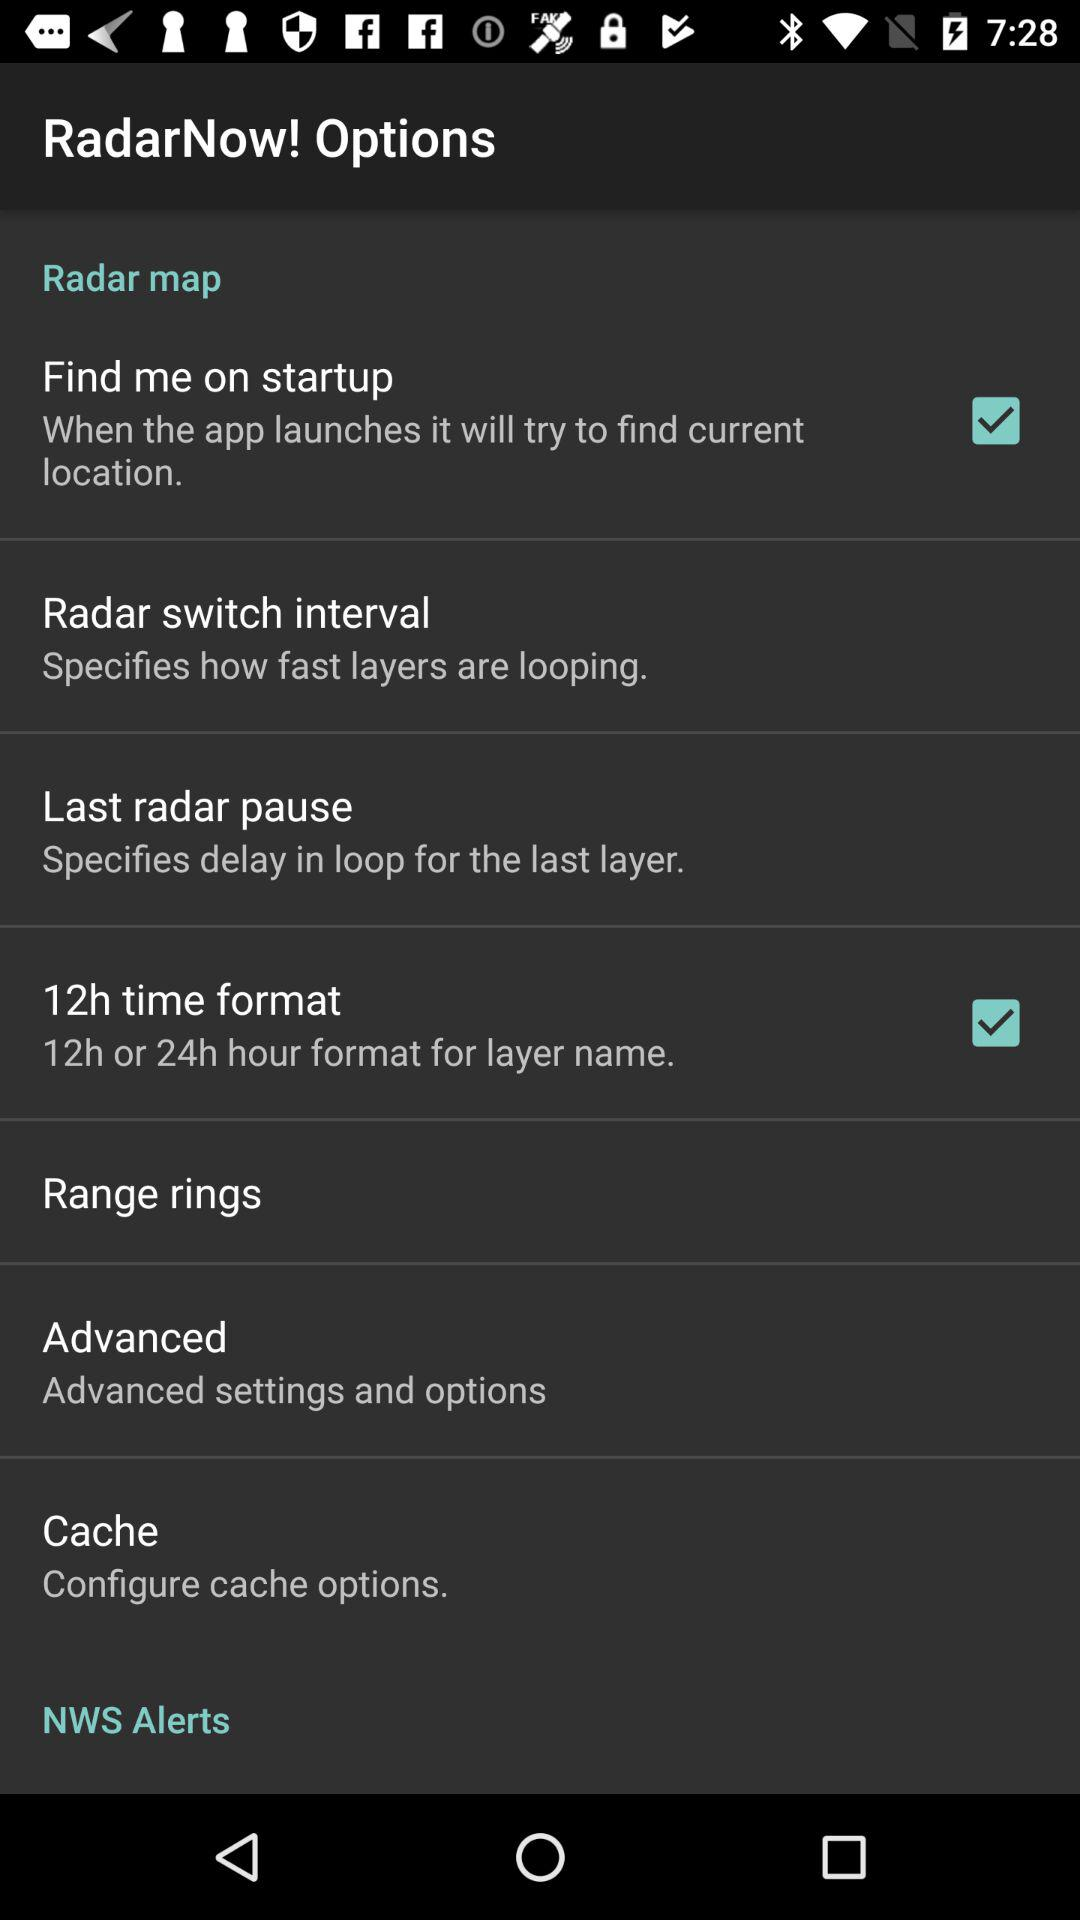What is the status of the "12h time format"? The status of the "12h time format" is "on". 